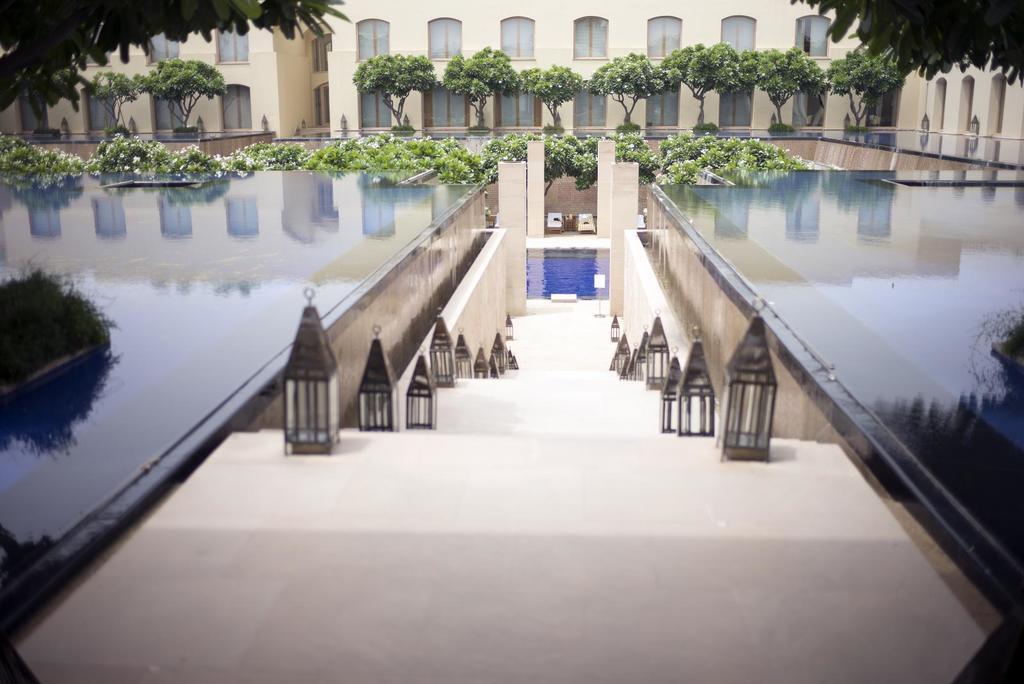In one or two sentences, can you explain what this image depicts? This is an outside view. In the middle of the image there are stairs. On both sides of the stairs there are few lanterns. On the right and left side of the image I can see the glass which seems to be the floor. In the background there are many flower plants, trees and a building. 